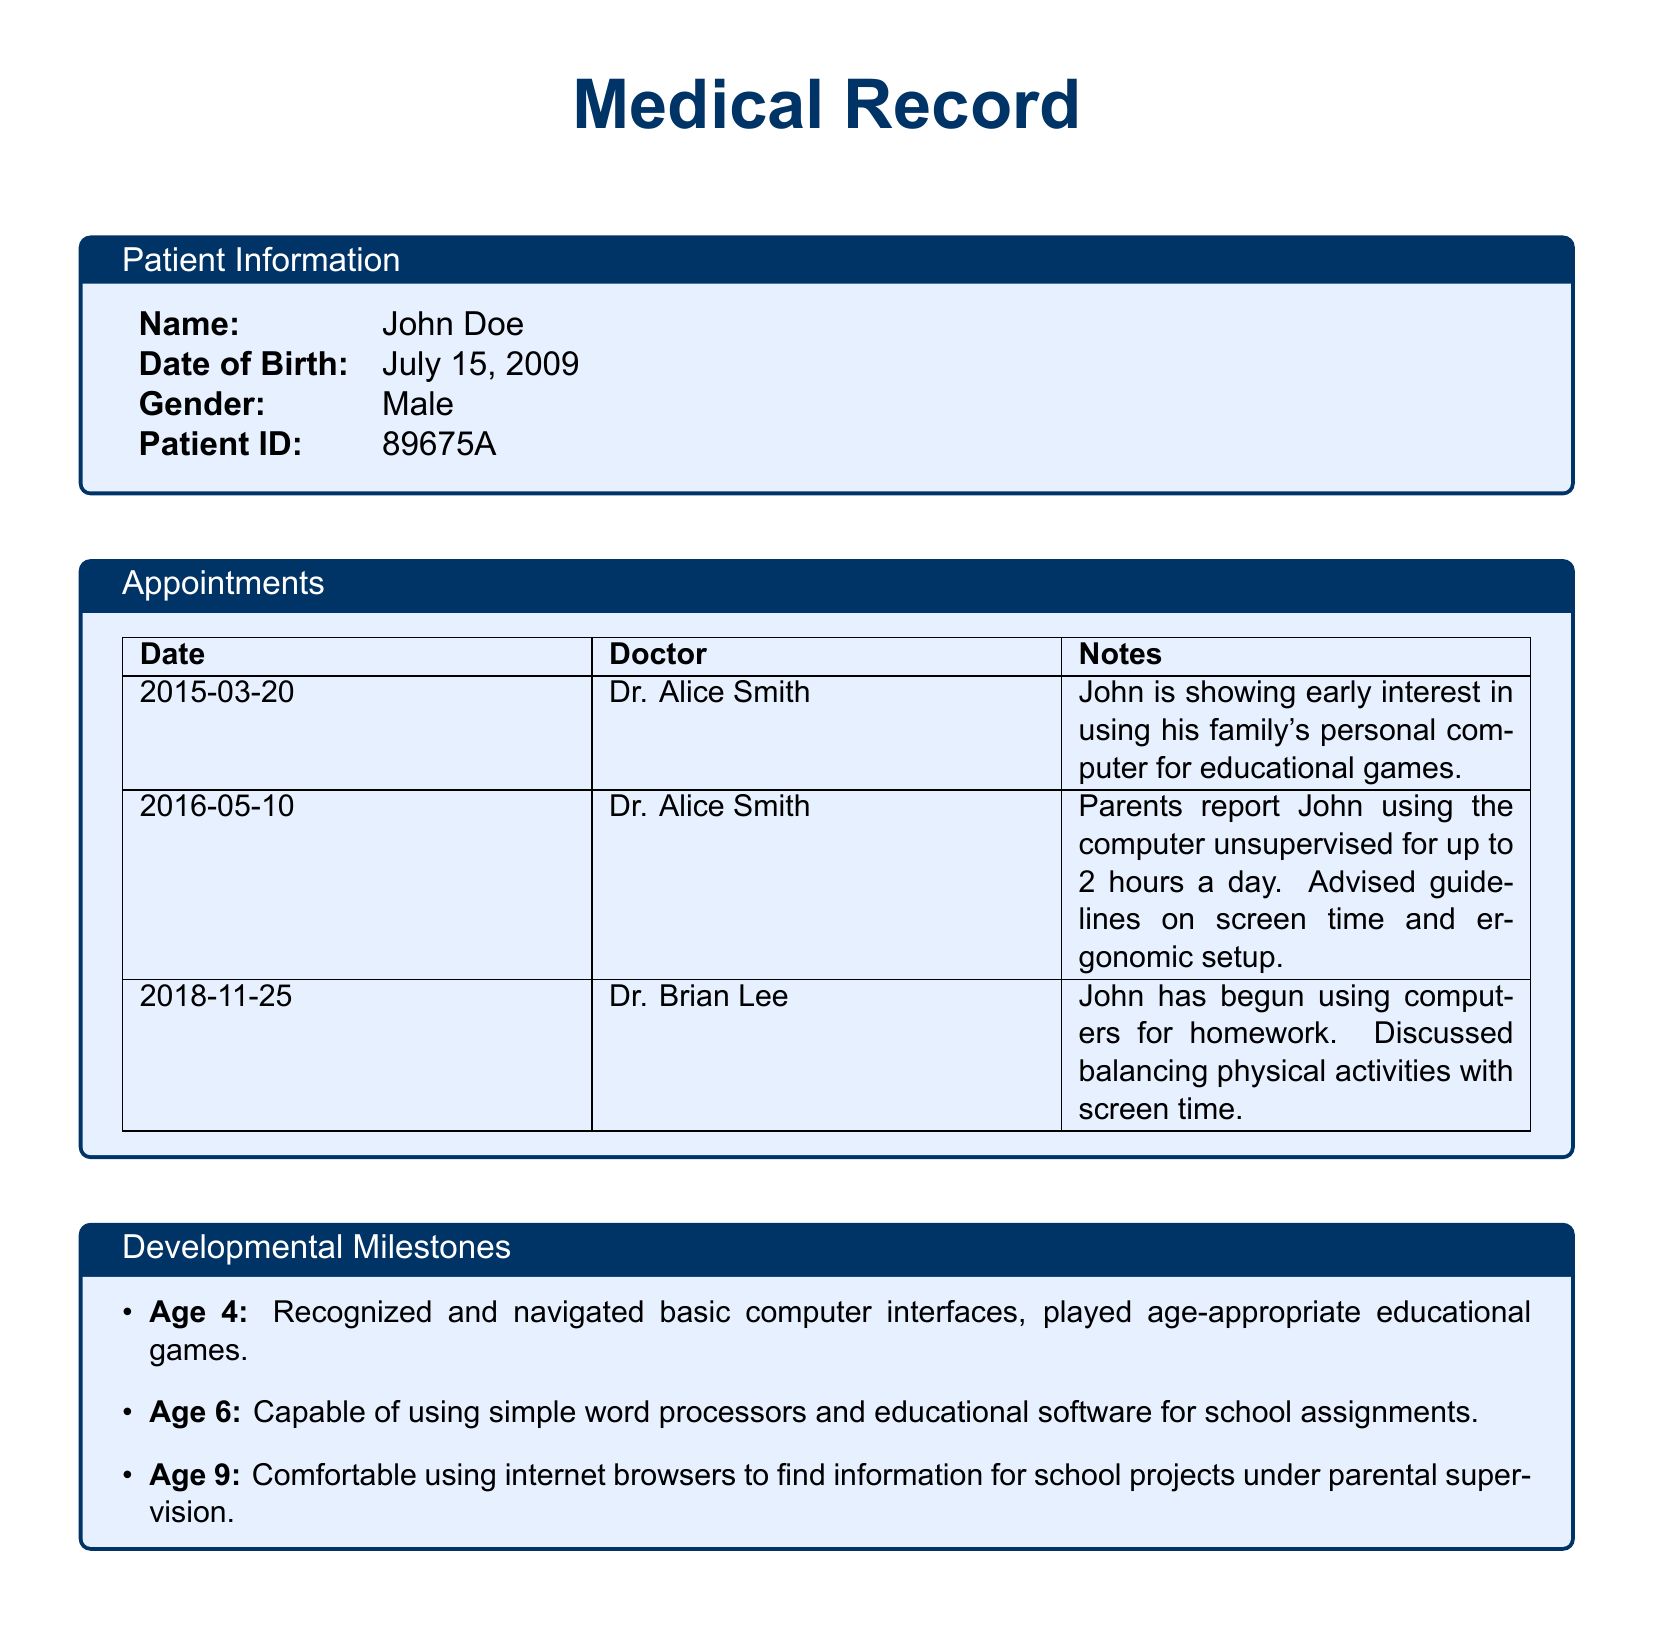What is the patient's name? The patient's name is specified in the Patient Information section of the document.
Answer: John Doe What is the date of birth of the patient? The date of birth can be found in the Patient Information section, listing when the patient was born.
Answer: July 15, 2009 Who is the doctor that noted early computer interaction? The doctor responsible for this note is indicated in the Appointments section, showing who took the observation.
Answer: Dr. Alice Smith At what age did the patient recognize and navigate basic computer interfaces? This information is listed under Developmental Milestones, detailing what the patient achieved at various ages.
Answer: Age 4 What recommendations were made for the patient's screen time? The recommendations for screen time are provided in the Long-Term Health Effects section concerning digital usage.
Answer: Limit screen time to 1 hour a day during weekends How many hours a day was the patient using the computer unsupervised by 2016? The unsupervised hours are documented in a specific appointment note highlighting computer use.
Answer: 2 hours What is one observation regarding the patient's cognitive development? Observations about cognitive development are outlined, noting specific intelligence measures or skills.
Answer: Advanced problem-solving skills What did the parents report during the appointment on May 10, 2016? This detail is provided in the appointment notes, reflecting what the parents discussed with the doctor.
Answer: John using the computer unsupervised for up to 2 hours a day What is the gender of the patient? The gender is specified in patient demographics in the document.
Answer: Male 